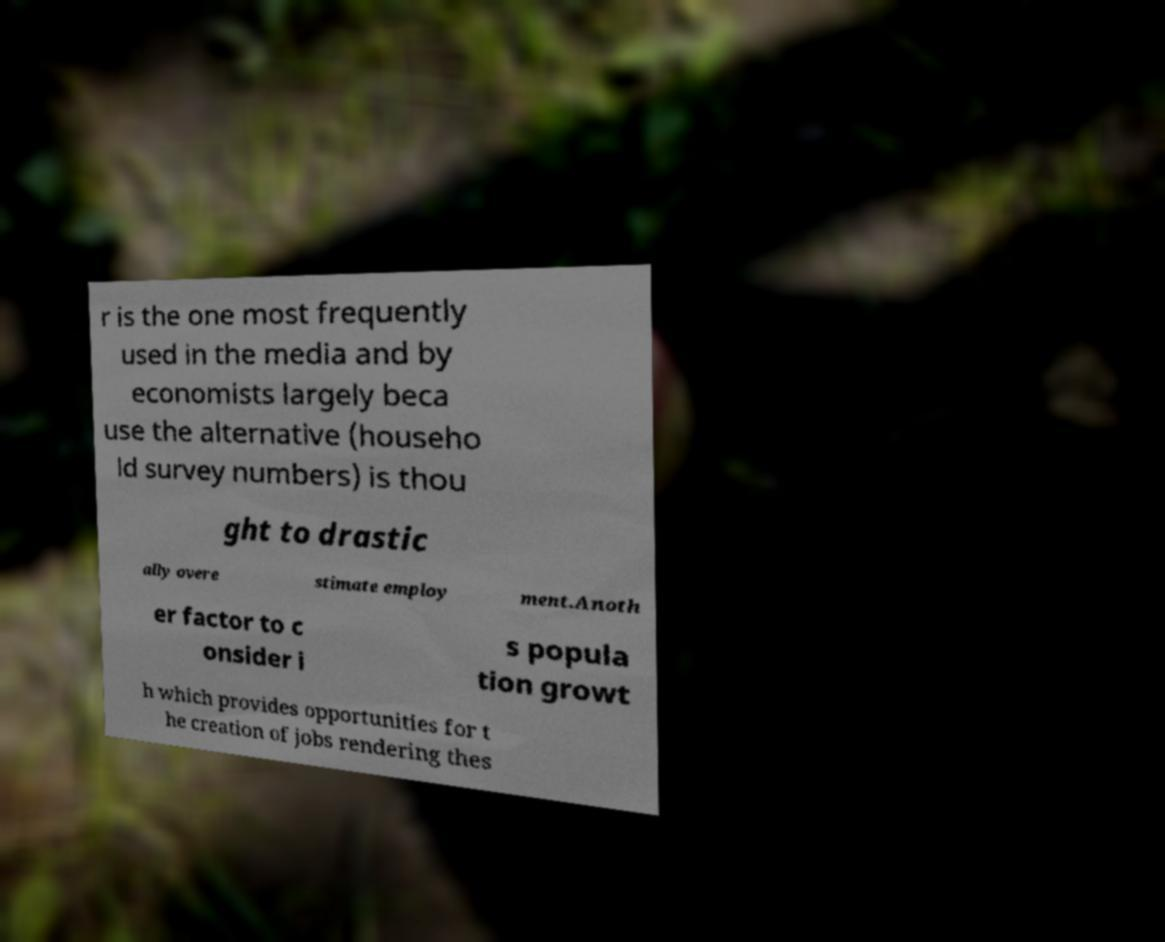What messages or text are displayed in this image? I need them in a readable, typed format. r is the one most frequently used in the media and by economists largely beca use the alternative (househo ld survey numbers) is thou ght to drastic ally overe stimate employ ment.Anoth er factor to c onsider i s popula tion growt h which provides opportunities for t he creation of jobs rendering thes 